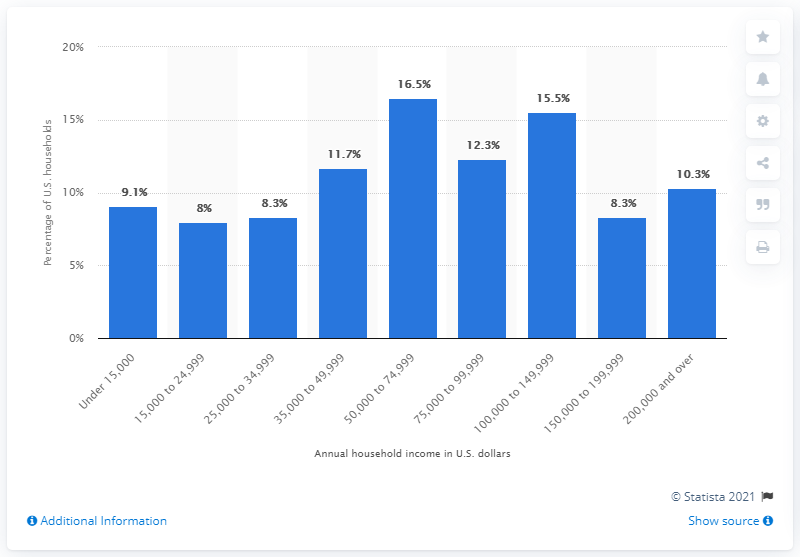Specify some key components in this picture. The sum of the first two bars (from the left) percentages is 17.1%. The graph does not contain sorted bars. 